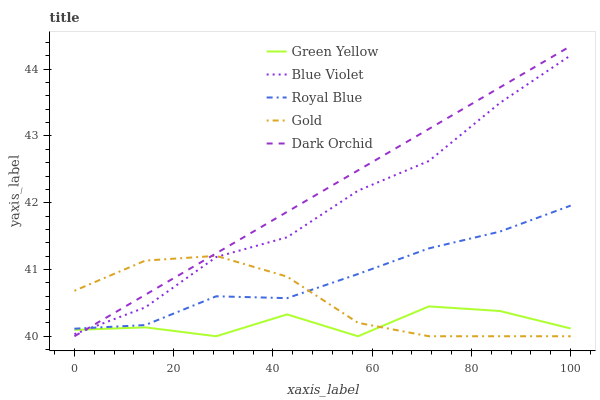Does Green Yellow have the minimum area under the curve?
Answer yes or no. Yes. Does Dark Orchid have the maximum area under the curve?
Answer yes or no. Yes. Does Royal Blue have the minimum area under the curve?
Answer yes or no. No. Does Royal Blue have the maximum area under the curve?
Answer yes or no. No. Is Dark Orchid the smoothest?
Answer yes or no. Yes. Is Green Yellow the roughest?
Answer yes or no. Yes. Is Royal Blue the smoothest?
Answer yes or no. No. Is Royal Blue the roughest?
Answer yes or no. No. Does Dark Orchid have the lowest value?
Answer yes or no. Yes. Does Royal Blue have the lowest value?
Answer yes or no. No. Does Dark Orchid have the highest value?
Answer yes or no. Yes. Does Royal Blue have the highest value?
Answer yes or no. No. Is Green Yellow less than Royal Blue?
Answer yes or no. Yes. Is Royal Blue greater than Green Yellow?
Answer yes or no. Yes. Does Gold intersect Royal Blue?
Answer yes or no. Yes. Is Gold less than Royal Blue?
Answer yes or no. No. Is Gold greater than Royal Blue?
Answer yes or no. No. Does Green Yellow intersect Royal Blue?
Answer yes or no. No. 